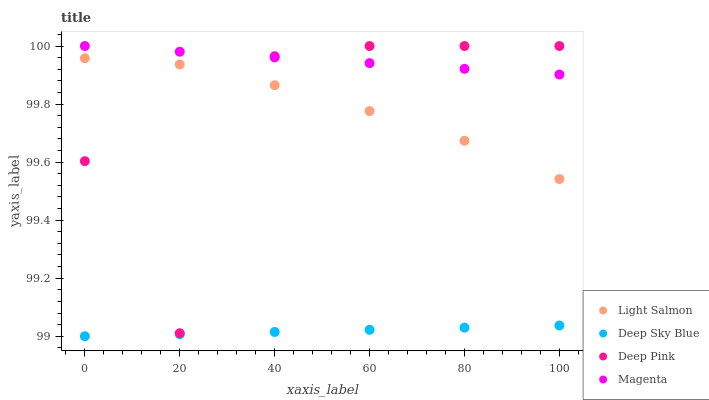Does Deep Sky Blue have the minimum area under the curve?
Answer yes or no. Yes. Does Magenta have the maximum area under the curve?
Answer yes or no. Yes. Does Deep Pink have the minimum area under the curve?
Answer yes or no. No. Does Deep Pink have the maximum area under the curve?
Answer yes or no. No. Is Deep Sky Blue the smoothest?
Answer yes or no. Yes. Is Deep Pink the roughest?
Answer yes or no. Yes. Is Magenta the smoothest?
Answer yes or no. No. Is Magenta the roughest?
Answer yes or no. No. Does Deep Sky Blue have the lowest value?
Answer yes or no. Yes. Does Deep Pink have the lowest value?
Answer yes or no. No. Does Magenta have the highest value?
Answer yes or no. Yes. Does Deep Sky Blue have the highest value?
Answer yes or no. No. Is Deep Sky Blue less than Magenta?
Answer yes or no. Yes. Is Light Salmon greater than Deep Sky Blue?
Answer yes or no. Yes. Does Magenta intersect Deep Pink?
Answer yes or no. Yes. Is Magenta less than Deep Pink?
Answer yes or no. No. Is Magenta greater than Deep Pink?
Answer yes or no. No. Does Deep Sky Blue intersect Magenta?
Answer yes or no. No. 